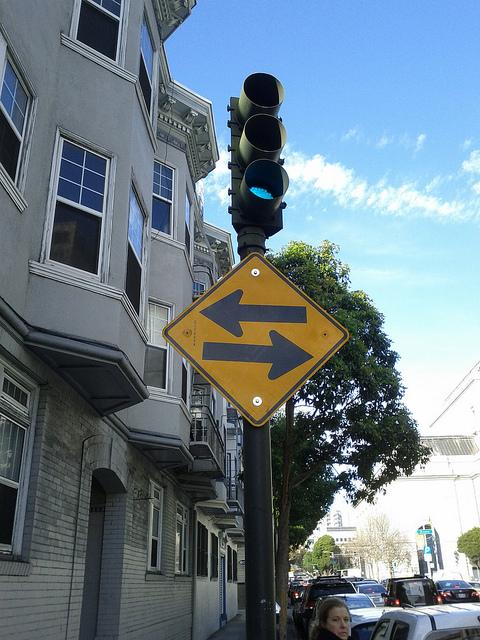Where does the woman stand at? crosswalk 